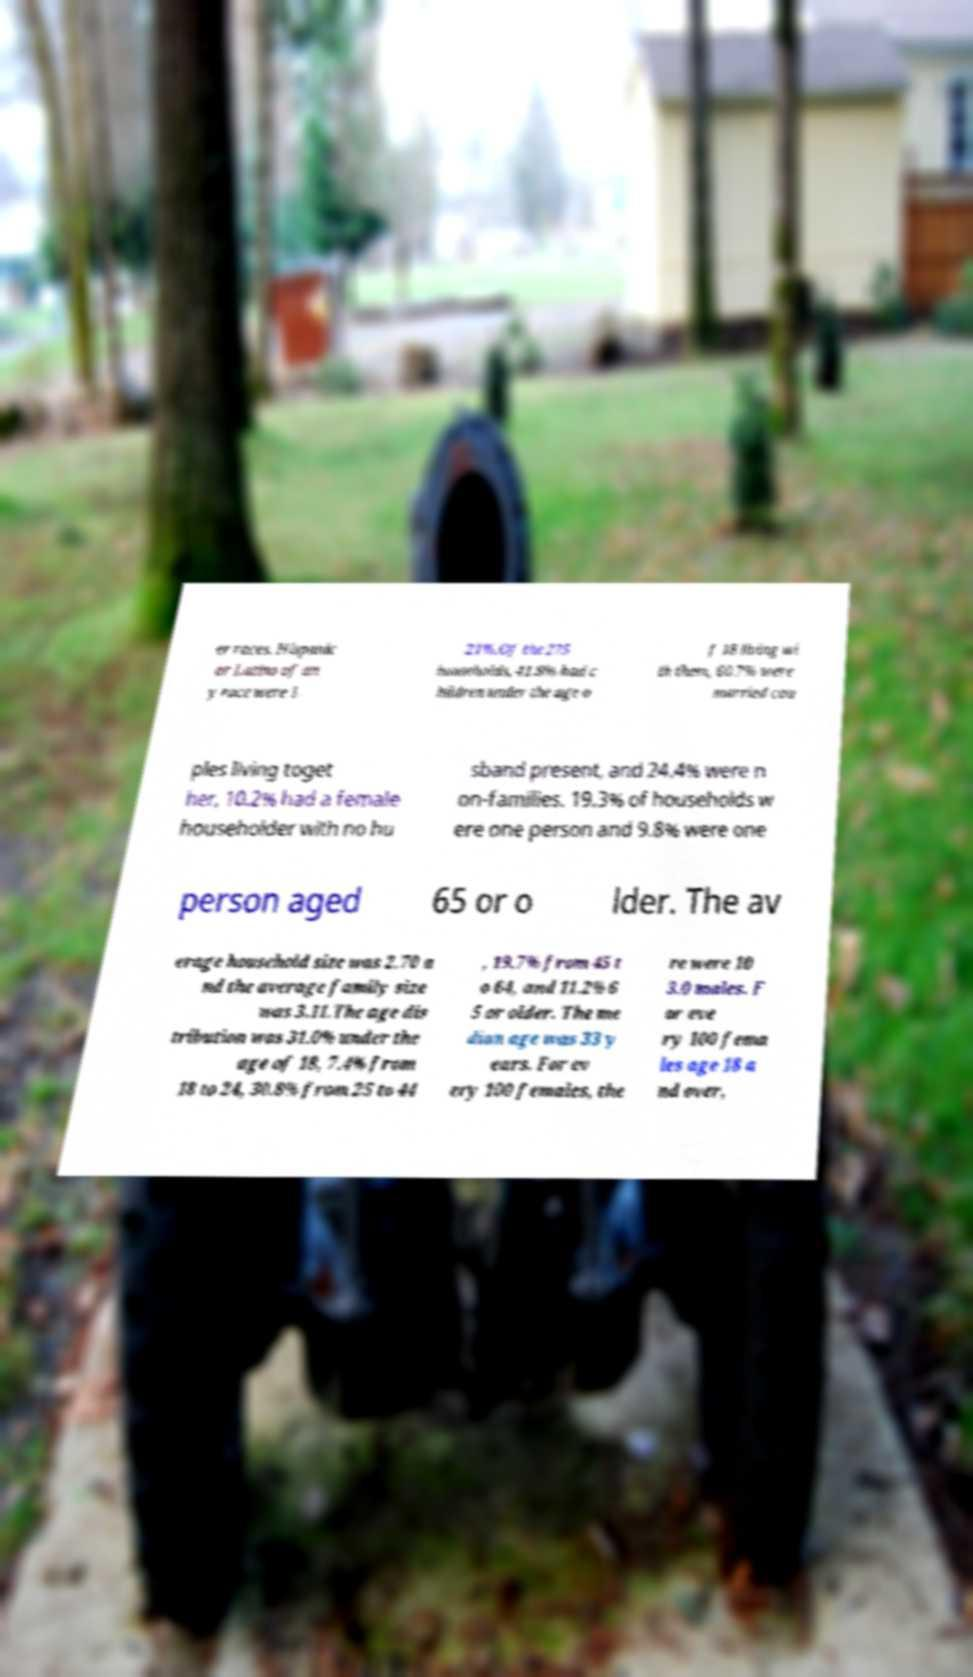Please read and relay the text visible in this image. What does it say? er races. Hispanic or Latino of an y race were 1. 21%.Of the 275 households, 41.8% had c hildren under the age o f 18 living wi th them, 60.7% were married cou ples living toget her, 10.2% had a female householder with no hu sband present, and 24.4% were n on-families. 19.3% of households w ere one person and 9.8% were one person aged 65 or o lder. The av erage household size was 2.70 a nd the average family size was 3.11.The age dis tribution was 31.0% under the age of 18, 7.4% from 18 to 24, 30.8% from 25 to 44 , 19.7% from 45 t o 64, and 11.2% 6 5 or older. The me dian age was 33 y ears. For ev ery 100 females, the re were 10 3.0 males. F or eve ry 100 fema les age 18 a nd over, 